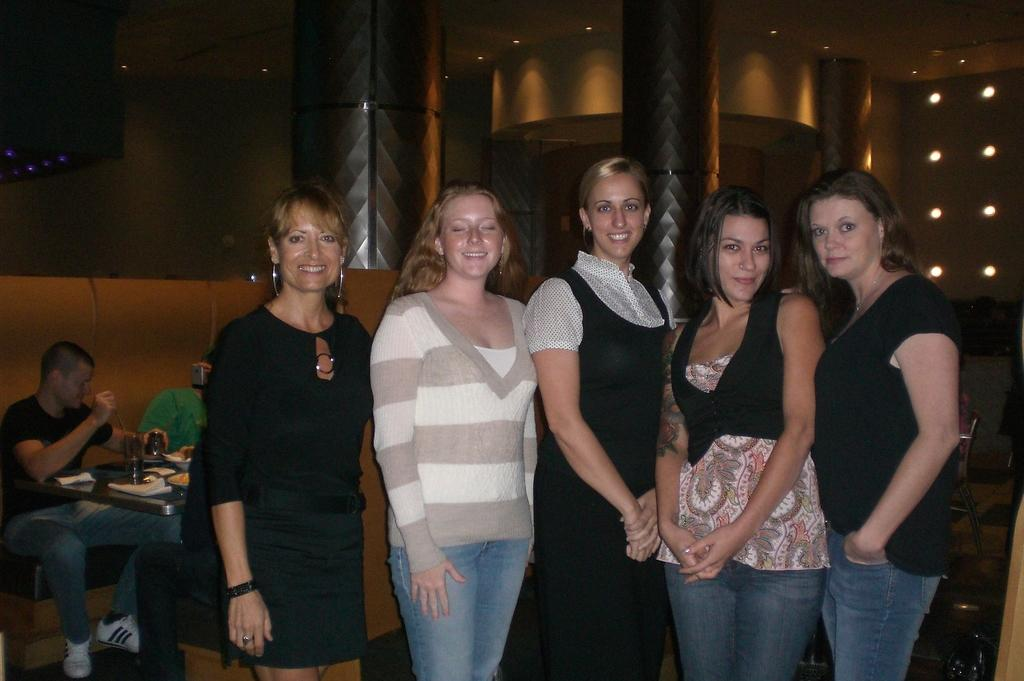What is the primary subject of the image? There are women standing in the image. Can you describe the setting or context of the image? In the background of the image, there are people sitting on a sofa. How long does it take for the cream to be applied in the image? There is no cream or application process depicted in the image. 